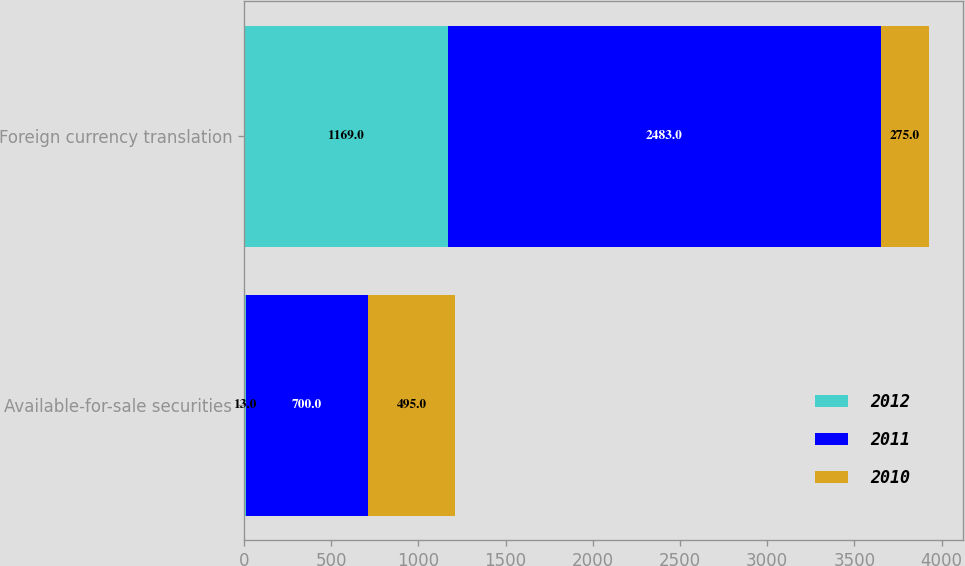Convert chart to OTSL. <chart><loc_0><loc_0><loc_500><loc_500><stacked_bar_chart><ecel><fcel>Available-for-sale securities<fcel>Foreign currency translation<nl><fcel>2012<fcel>13<fcel>1169<nl><fcel>2011<fcel>700<fcel>2483<nl><fcel>2010<fcel>495<fcel>275<nl></chart> 